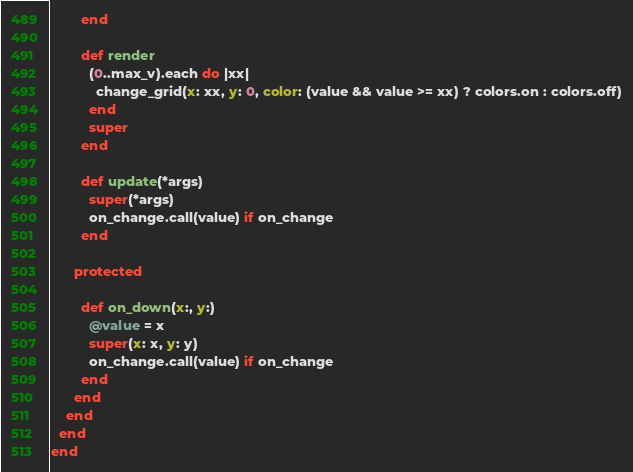Convert code to text. <code><loc_0><loc_0><loc_500><loc_500><_Ruby_>        end

        def render
          (0..max_v).each do |xx|
            change_grid(x: xx, y: 0, color: (value && value >= xx) ? colors.on : colors.off)
          end
          super
        end

        def update(*args)
          super(*args)
          on_change.call(value) if on_change
        end

      protected

        def on_down(x:, y:)
          @value = x
          super(x: x, y: y)
          on_change.call(value) if on_change
        end
      end
    end
  end
end
</code> 